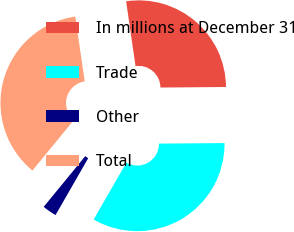Convert chart. <chart><loc_0><loc_0><loc_500><loc_500><pie_chart><fcel>In millions at December 31<fcel>Trade<fcel>Other<fcel>Total<nl><fcel>27.16%<fcel>33.43%<fcel>2.63%<fcel>36.78%<nl></chart> 